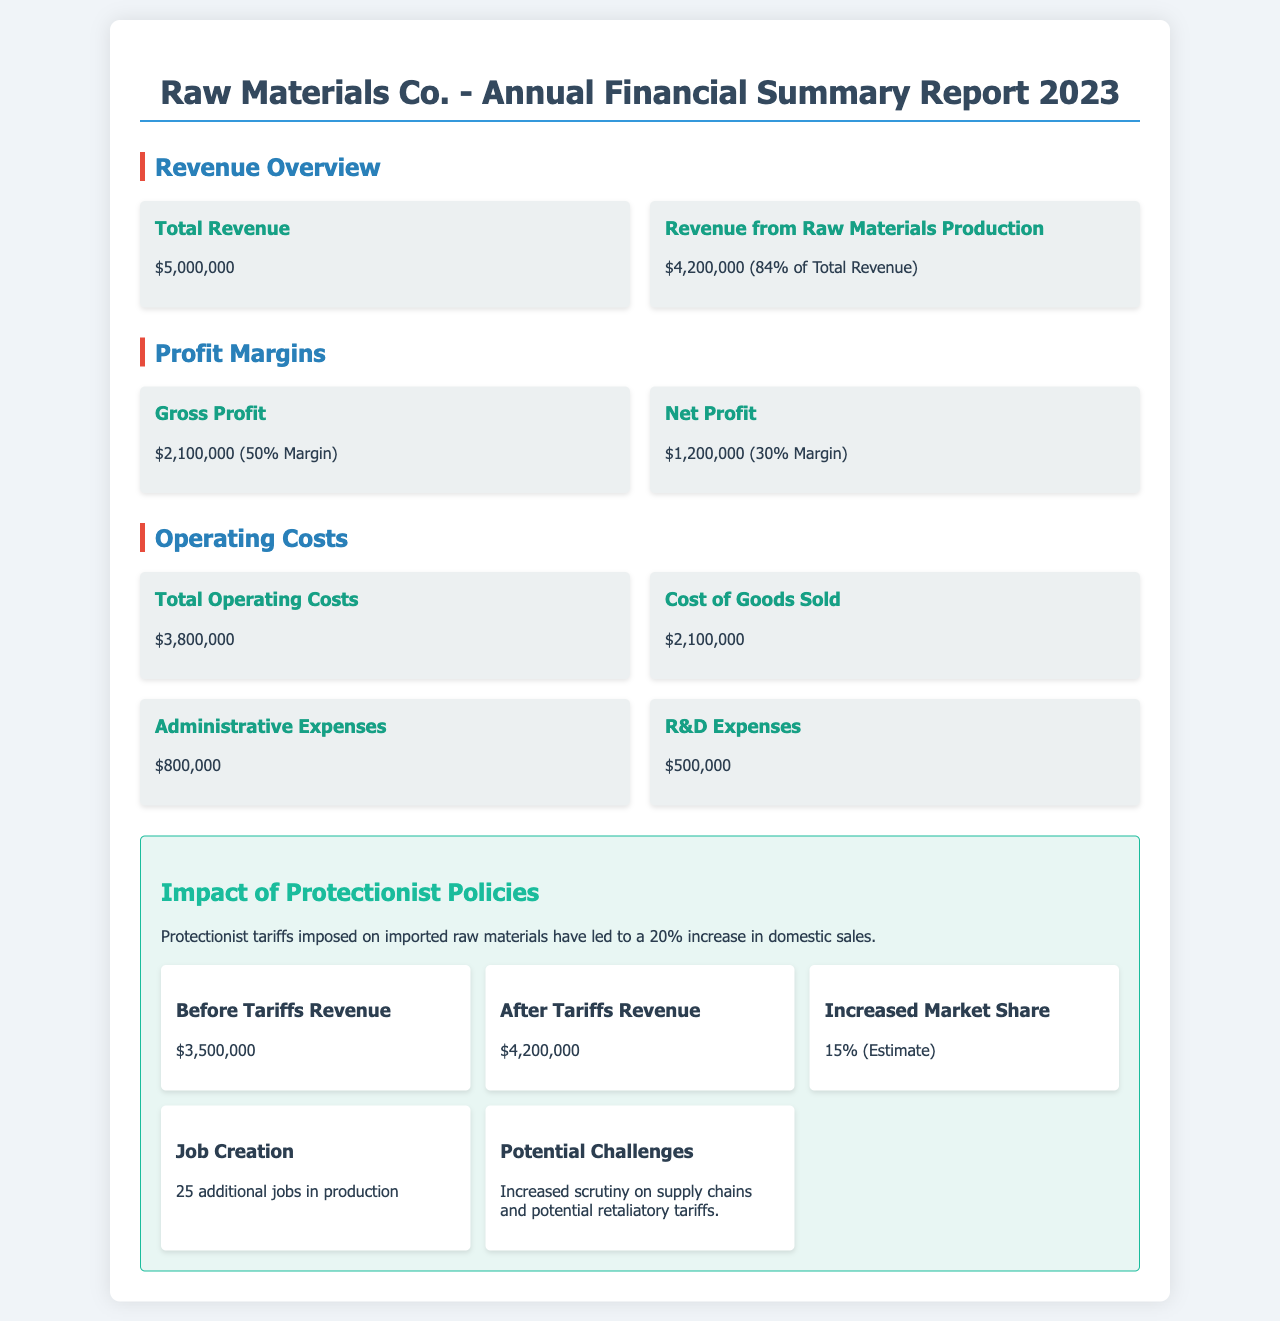What is the total revenue? The total revenue is stated in the document as the full amount, which is $5,000,000.
Answer: $5,000,000 What percentage of total revenue comes from raw materials production? The document specifies that revenue from raw materials production makes up 84% of the total revenue.
Answer: 84% What is the gross profit amount? The document mentions the gross profit is $2,100,000, indicating the profit after subtracting the cost of goods sold.
Answer: $2,100,000 By how much did domestic sales increase due to protectionist policies? The document states that there was a 20% increase in domestic sales due to protectionist tariffs.
Answer: 20% What was the revenue before tariffs? The document indicates that the revenue before tariffs was $3,500,000.
Answer: $3,500,000 How many additional jobs were created? According to the document, 25 additional jobs in production were created.
Answer: 25 What is the net profit amount? The net profit stated in the document is $1,200,000.
Answer: $1,200,000 What are the administrative expenses? The administrative expenses are given as $800,000 in the financial summary document.
Answer: $800,000 What is the amount for Research and Development expenses? The document lists the R&D expenses as $500,000.
Answer: $500,000 